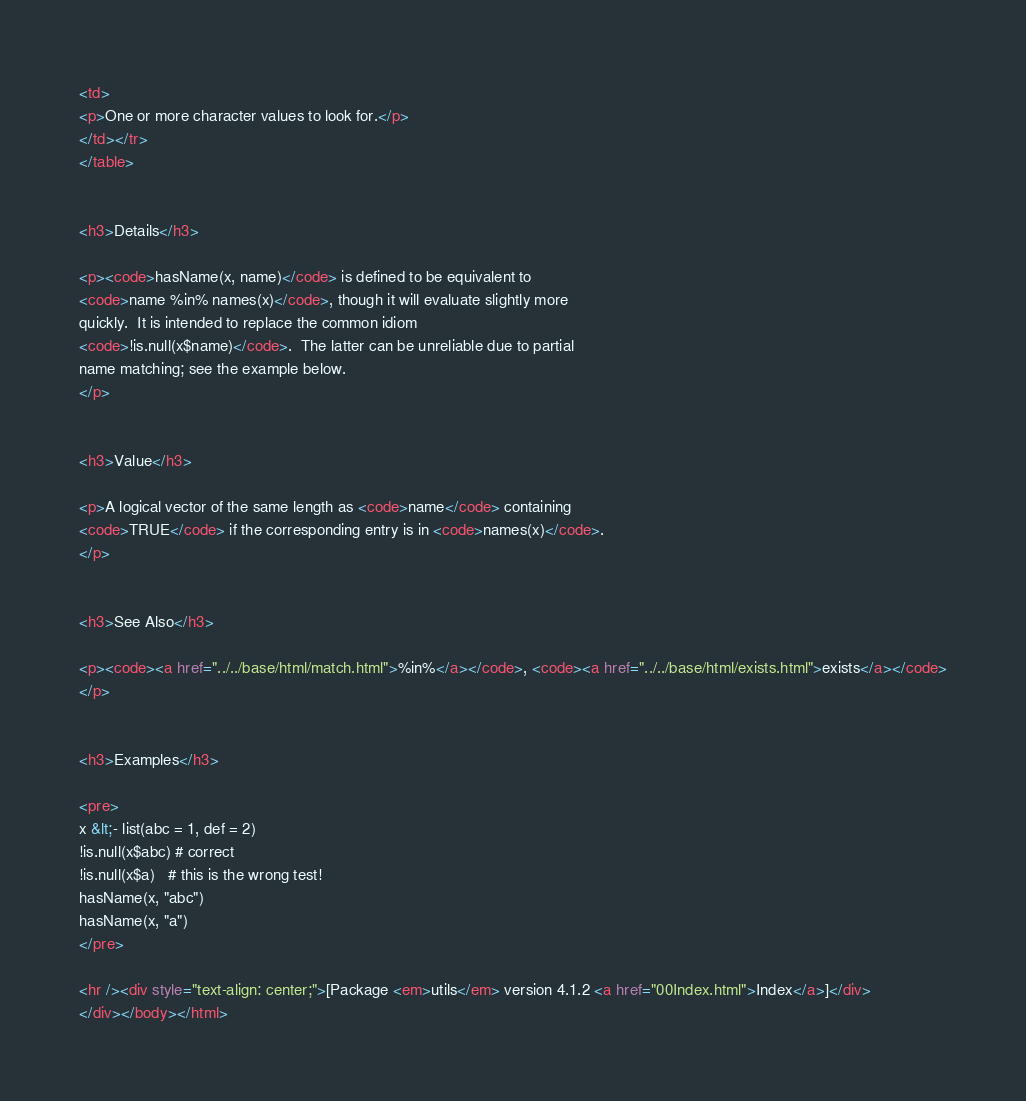Convert code to text. <code><loc_0><loc_0><loc_500><loc_500><_HTML_><td>
<p>One or more character values to look for.</p>
</td></tr>
</table>


<h3>Details</h3>

<p><code>hasName(x, name)</code> is defined to be equivalent to 
<code>name %in% names(x)</code>, though it will evaluate slightly more
quickly.  It is intended to replace the common idiom
<code>!is.null(x$name)</code>.  The latter can be unreliable due to partial
name matching; see the example below.
</p>


<h3>Value</h3>

<p>A logical vector of the same length as <code>name</code> containing
<code>TRUE</code> if the corresponding entry is in <code>names(x)</code>.
</p>


<h3>See Also</h3>

<p><code><a href="../../base/html/match.html">%in%</a></code>, <code><a href="../../base/html/exists.html">exists</a></code>
</p>


<h3>Examples</h3>

<pre>
x &lt;- list(abc = 1, def = 2)
!is.null(x$abc) # correct
!is.null(x$a)   # this is the wrong test!
hasName(x, "abc")
hasName(x, "a")
</pre>

<hr /><div style="text-align: center;">[Package <em>utils</em> version 4.1.2 <a href="00Index.html">Index</a>]</div>
</div></body></html>
</code> 